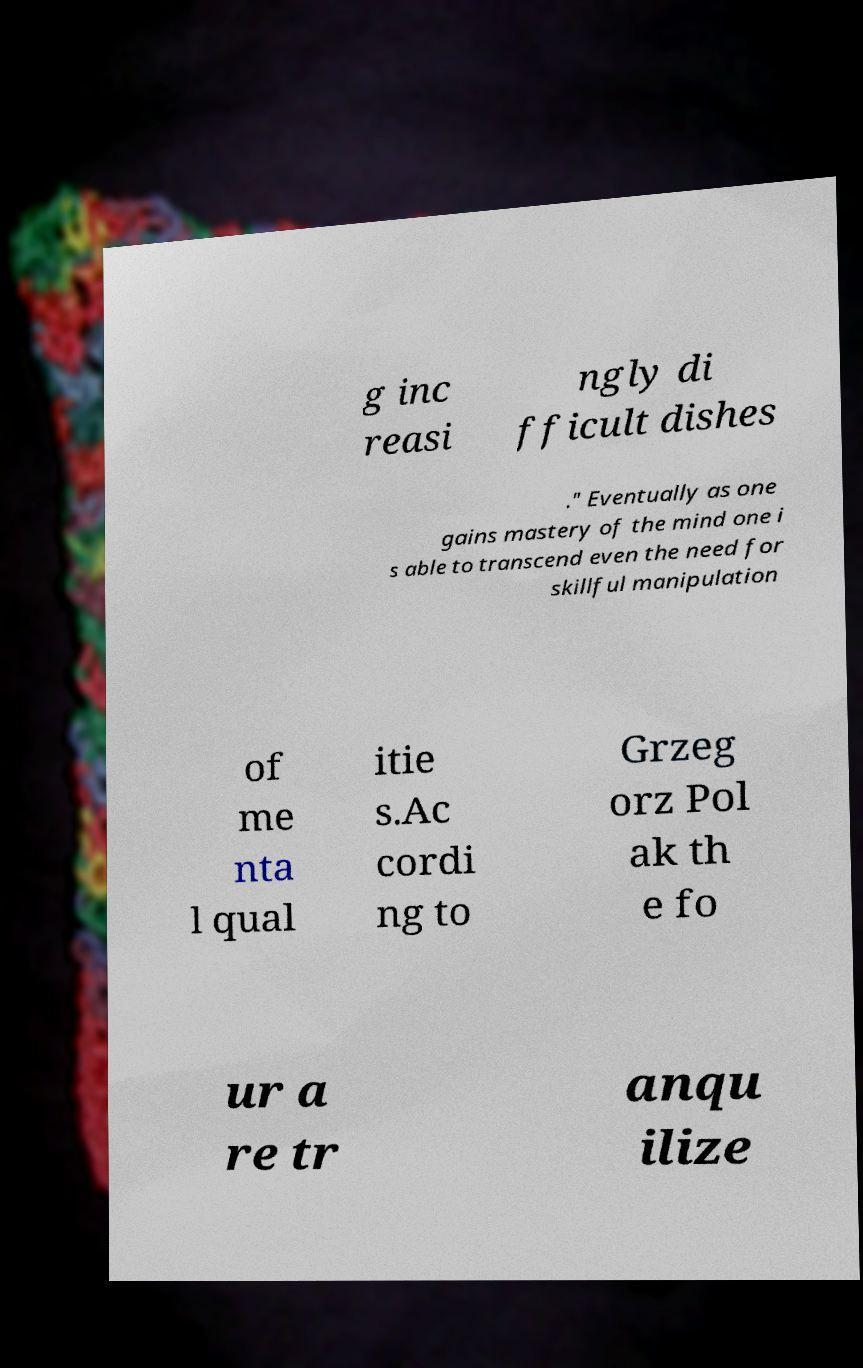Can you accurately transcribe the text from the provided image for me? g inc reasi ngly di fficult dishes ." Eventually as one gains mastery of the mind one i s able to transcend even the need for skillful manipulation of me nta l qual itie s.Ac cordi ng to Grzeg orz Pol ak th e fo ur a re tr anqu ilize 